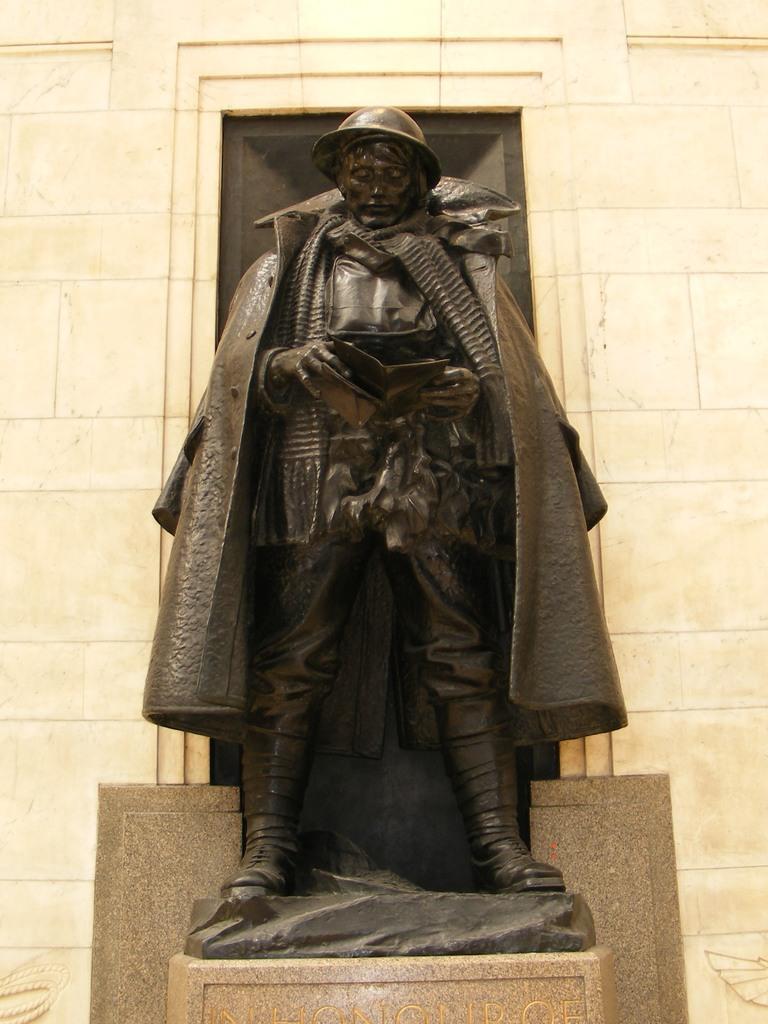Can you describe this image briefly? In this picture we can see sculpture on the platform. In the background of the image we can see wall. 